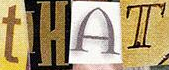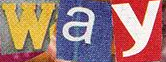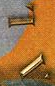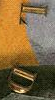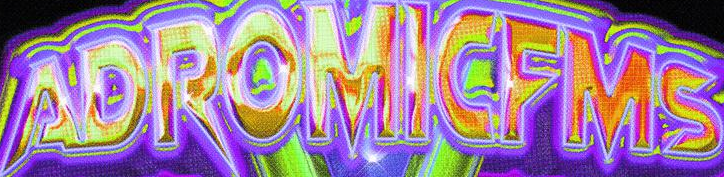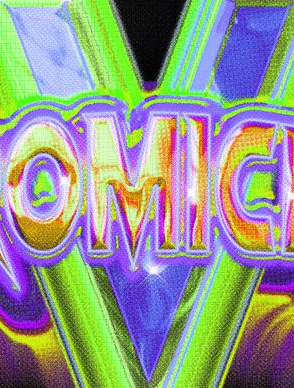Read the text from these images in sequence, separated by a semicolon. tHAT; way; AL; LD; ADROMICFMS; V 